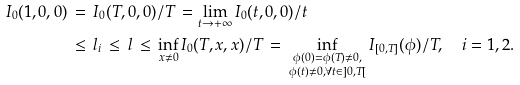<formula> <loc_0><loc_0><loc_500><loc_500>I _ { 0 } ( 1 , 0 , 0 ) \, & = \, I _ { 0 } ( T , 0 , 0 ) / T \, = \lim _ { t \to + \infty } I _ { 0 } ( t , 0 , 0 ) / t \\ & \leq \, l _ { i } \, \leq \, l \, \leq \, \inf _ { x \not = 0 } I _ { 0 } ( T , x , x ) / T \, = \, \inf _ { \substack { \phi ( 0 ) = \phi ( T ) \not = 0 , \\ \phi ( t ) \not = 0 , \forall t \in ] 0 , T [ } } I _ { [ 0 , T ] } ( \phi ) / T , \quad i = 1 , 2 .</formula> 